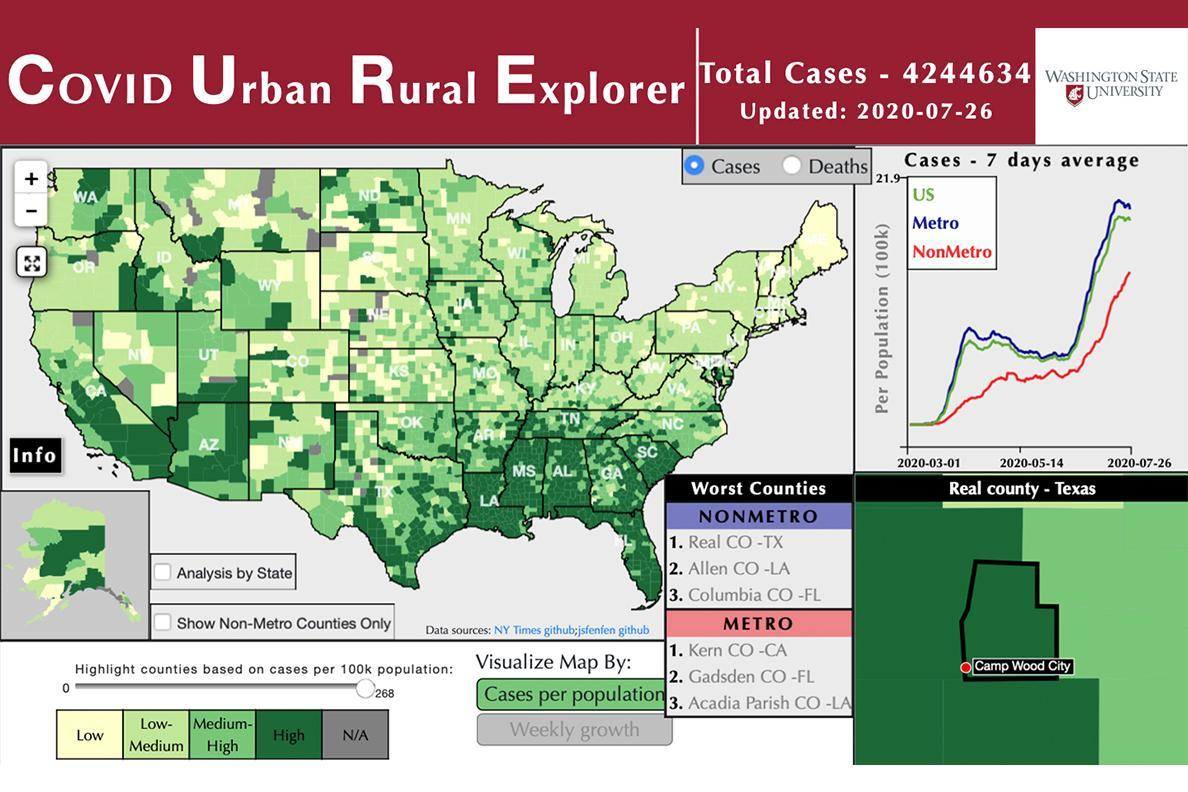In the graph representing cases-7 days average, which region is the blue line indicating
Answer the question with a short phrase. Metro In US, between Metro and NonMetro, which region is more impacted Metro In the graph representing cases-7 days average, which region is the green line indicating US In the graph representing cases-7 days average, which region is the red line indicating NonMetro 